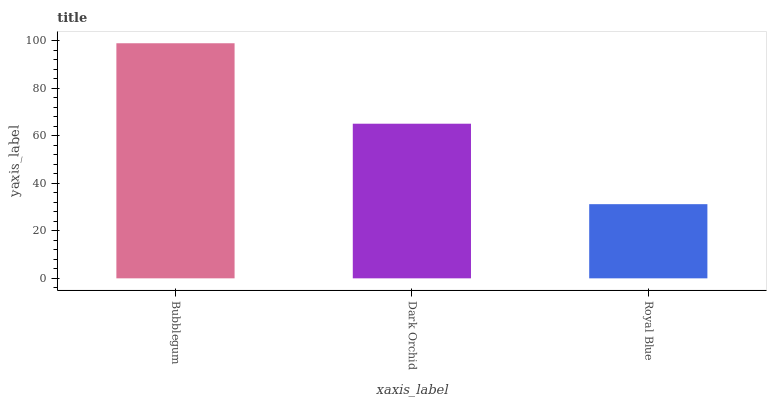Is Royal Blue the minimum?
Answer yes or no. Yes. Is Bubblegum the maximum?
Answer yes or no. Yes. Is Dark Orchid the minimum?
Answer yes or no. No. Is Dark Orchid the maximum?
Answer yes or no. No. Is Bubblegum greater than Dark Orchid?
Answer yes or no. Yes. Is Dark Orchid less than Bubblegum?
Answer yes or no. Yes. Is Dark Orchid greater than Bubblegum?
Answer yes or no. No. Is Bubblegum less than Dark Orchid?
Answer yes or no. No. Is Dark Orchid the high median?
Answer yes or no. Yes. Is Dark Orchid the low median?
Answer yes or no. Yes. Is Royal Blue the high median?
Answer yes or no. No. Is Bubblegum the low median?
Answer yes or no. No. 